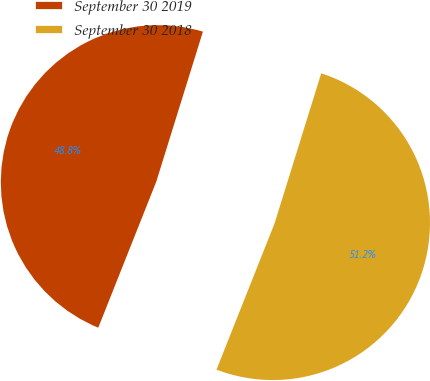Convert chart to OTSL. <chart><loc_0><loc_0><loc_500><loc_500><pie_chart><fcel>September 30 2019<fcel>September 30 2018<nl><fcel>48.78%<fcel>51.22%<nl></chart> 